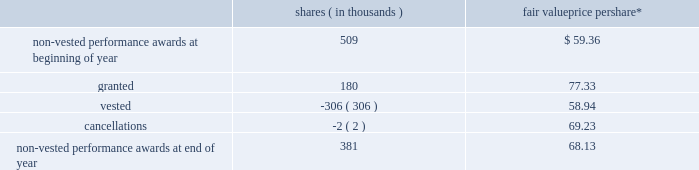The fair value of performance awards is calculated using the market value of a share of snap-on 2019s common stock on the date of grant .
The weighted-average grant date fair value of performance awards granted during 2013 , 2012 and 2011 was $ 77.33 , $ 60.00 and $ 55.97 , respectively .
Vested performance share units approximated 148000 shares as of 2013 year end , 213000 shares as of 2012 year end and 54208 shares as of 2011 year end .
Performance share units of 213459 shares were paid out in 2013 and 53990 shares were paid out in 2012 ; no performance share units were paid out in 2011 .
Earned performance share units are generally paid out following the conclusion of the applicable performance period upon approval by the organization and executive compensation committee of the company 2019s board of directors ( the 201cboard 201d ) .
Based on the company 2019s 2013 performance , 84413 rsus granted in 2013 were earned ; assuming continued employment , these rsus will vest at the end of fiscal 2015 .
Based on the company 2019s 2012 performance , 95047 rsus granted in 2012 were earned ; assuming continued employment , these rsus will vest at the end of fiscal 2014 .
Based on the company 2019s 2011 performance , 159970 rsus granted in 2011 were earned ; these rsus vested as of fiscal 2013 year end and were paid out shortly thereafter .
As a result of employee retirements , a total of 1614 of the rsus earned in 2012 and 2011 vested pursuant to the terms of the related award agreements and the underlying shares were paid out in the third quarter of 2013 .
The changes to the company 2019s non-vested performance awards in 2013 are as follows : shares ( in thousands ) fair value price per share* .
* weighted-average as of 2013 year end there was approximately $ 12.9 million of unrecognized compensation cost related to non-vested performance awards that is expected to be recognized as a charge to earnings over a weighted-average period of 1.6 years .
Stock appreciation rights ( 201csars 201d ) the company also issues cash-settled and stock-settled sars to certain key non-u.s .
Employees .
Sars have a contractual term of ten years and vest ratably on the first , second and third anniversaries of the date of grant .
Sars are granted with an exercise price equal to the market value of a share of snap-on 2019s common stock on the date of grant .
Cash-settled sars provide for the cash payment of the excess of the fair market value of snap-on 2019s common stock price on the date of exercise over the grant price .
Cash-settled sars have no effect on dilutive shares or shares outstanding as any appreciation of snap-on 2019s common stock value over the grant price is paid in cash and not in common stock .
In 2013 , the company began issuing stock-settled sars that are accounted for as equity instruments and provide for the issuance of snap-on common stock equal to the amount by which the company 2019s stock has appreciated over the exercise price .
Stock-settled sars have an effect on dilutive shares and shares outstanding as any appreciation of snap-on 2019s common stock value over the exercise price will be settled in shares of common stock .
2013 annual report 101 .
What was the average approximate vested performance share units from 2011 to 2013? 
Computations: (54208 + (148000 + 213000))
Answer: 415208.0. The fair value of performance awards is calculated using the market value of a share of snap-on 2019s common stock on the date of grant .
The weighted-average grant date fair value of performance awards granted during 2013 , 2012 and 2011 was $ 77.33 , $ 60.00 and $ 55.97 , respectively .
Vested performance share units approximated 148000 shares as of 2013 year end , 213000 shares as of 2012 year end and 54208 shares as of 2011 year end .
Performance share units of 213459 shares were paid out in 2013 and 53990 shares were paid out in 2012 ; no performance share units were paid out in 2011 .
Earned performance share units are generally paid out following the conclusion of the applicable performance period upon approval by the organization and executive compensation committee of the company 2019s board of directors ( the 201cboard 201d ) .
Based on the company 2019s 2013 performance , 84413 rsus granted in 2013 were earned ; assuming continued employment , these rsus will vest at the end of fiscal 2015 .
Based on the company 2019s 2012 performance , 95047 rsus granted in 2012 were earned ; assuming continued employment , these rsus will vest at the end of fiscal 2014 .
Based on the company 2019s 2011 performance , 159970 rsus granted in 2011 were earned ; these rsus vested as of fiscal 2013 year end and were paid out shortly thereafter .
As a result of employee retirements , a total of 1614 of the rsus earned in 2012 and 2011 vested pursuant to the terms of the related award agreements and the underlying shares were paid out in the third quarter of 2013 .
The changes to the company 2019s non-vested performance awards in 2013 are as follows : shares ( in thousands ) fair value price per share* .
* weighted-average as of 2013 year end there was approximately $ 12.9 million of unrecognized compensation cost related to non-vested performance awards that is expected to be recognized as a charge to earnings over a weighted-average period of 1.6 years .
Stock appreciation rights ( 201csars 201d ) the company also issues cash-settled and stock-settled sars to certain key non-u.s .
Employees .
Sars have a contractual term of ten years and vest ratably on the first , second and third anniversaries of the date of grant .
Sars are granted with an exercise price equal to the market value of a share of snap-on 2019s common stock on the date of grant .
Cash-settled sars provide for the cash payment of the excess of the fair market value of snap-on 2019s common stock price on the date of exercise over the grant price .
Cash-settled sars have no effect on dilutive shares or shares outstanding as any appreciation of snap-on 2019s common stock value over the grant price is paid in cash and not in common stock .
In 2013 , the company began issuing stock-settled sars that are accounted for as equity instruments and provide for the issuance of snap-on common stock equal to the amount by which the company 2019s stock has appreciated over the exercise price .
Stock-settled sars have an effect on dilutive shares and shares outstanding as any appreciation of snap-on 2019s common stock value over the exercise price will be settled in shares of common stock .
2013 annual report 101 .
What was the percent of the change in the non-vested performance awards at end of year? 
Computations: ((381 - 509) / 509)
Answer: -0.25147. The fair value of performance awards is calculated using the market value of a share of snap-on 2019s common stock on the date of grant .
The weighted-average grant date fair value of performance awards granted during 2013 , 2012 and 2011 was $ 77.33 , $ 60.00 and $ 55.97 , respectively .
Vested performance share units approximated 148000 shares as of 2013 year end , 213000 shares as of 2012 year end and 54208 shares as of 2011 year end .
Performance share units of 213459 shares were paid out in 2013 and 53990 shares were paid out in 2012 ; no performance share units were paid out in 2011 .
Earned performance share units are generally paid out following the conclusion of the applicable performance period upon approval by the organization and executive compensation committee of the company 2019s board of directors ( the 201cboard 201d ) .
Based on the company 2019s 2013 performance , 84413 rsus granted in 2013 were earned ; assuming continued employment , these rsus will vest at the end of fiscal 2015 .
Based on the company 2019s 2012 performance , 95047 rsus granted in 2012 were earned ; assuming continued employment , these rsus will vest at the end of fiscal 2014 .
Based on the company 2019s 2011 performance , 159970 rsus granted in 2011 were earned ; these rsus vested as of fiscal 2013 year end and were paid out shortly thereafter .
As a result of employee retirements , a total of 1614 of the rsus earned in 2012 and 2011 vested pursuant to the terms of the related award agreements and the underlying shares were paid out in the third quarter of 2013 .
The changes to the company 2019s non-vested performance awards in 2013 are as follows : shares ( in thousands ) fair value price per share* .
* weighted-average as of 2013 year end there was approximately $ 12.9 million of unrecognized compensation cost related to non-vested performance awards that is expected to be recognized as a charge to earnings over a weighted-average period of 1.6 years .
Stock appreciation rights ( 201csars 201d ) the company also issues cash-settled and stock-settled sars to certain key non-u.s .
Employees .
Sars have a contractual term of ten years and vest ratably on the first , second and third anniversaries of the date of grant .
Sars are granted with an exercise price equal to the market value of a share of snap-on 2019s common stock on the date of grant .
Cash-settled sars provide for the cash payment of the excess of the fair market value of snap-on 2019s common stock price on the date of exercise over the grant price .
Cash-settled sars have no effect on dilutive shares or shares outstanding as any appreciation of snap-on 2019s common stock value over the grant price is paid in cash and not in common stock .
In 2013 , the company began issuing stock-settled sars that are accounted for as equity instruments and provide for the issuance of snap-on common stock equal to the amount by which the company 2019s stock has appreciated over the exercise price .
Stock-settled sars have an effect on dilutive shares and shares outstanding as any appreciation of snap-on 2019s common stock value over the exercise price will be settled in shares of common stock .
2013 annual report 101 .
What is the total value of non-vested performance awards at end of year , ( in millions ) ? 
Computations: ((381 - 68.13) / 1000)
Answer: 0.31287. 